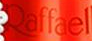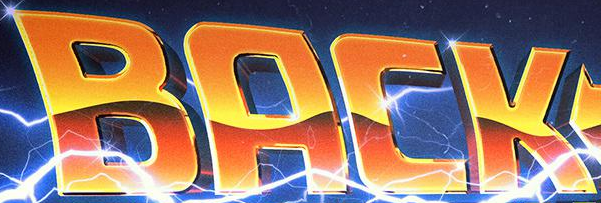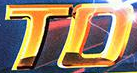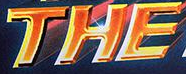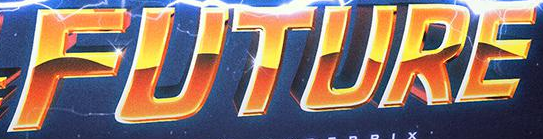Read the text content from these images in order, separated by a semicolon. Raffael; BACK; TO; THE; FUTURE 